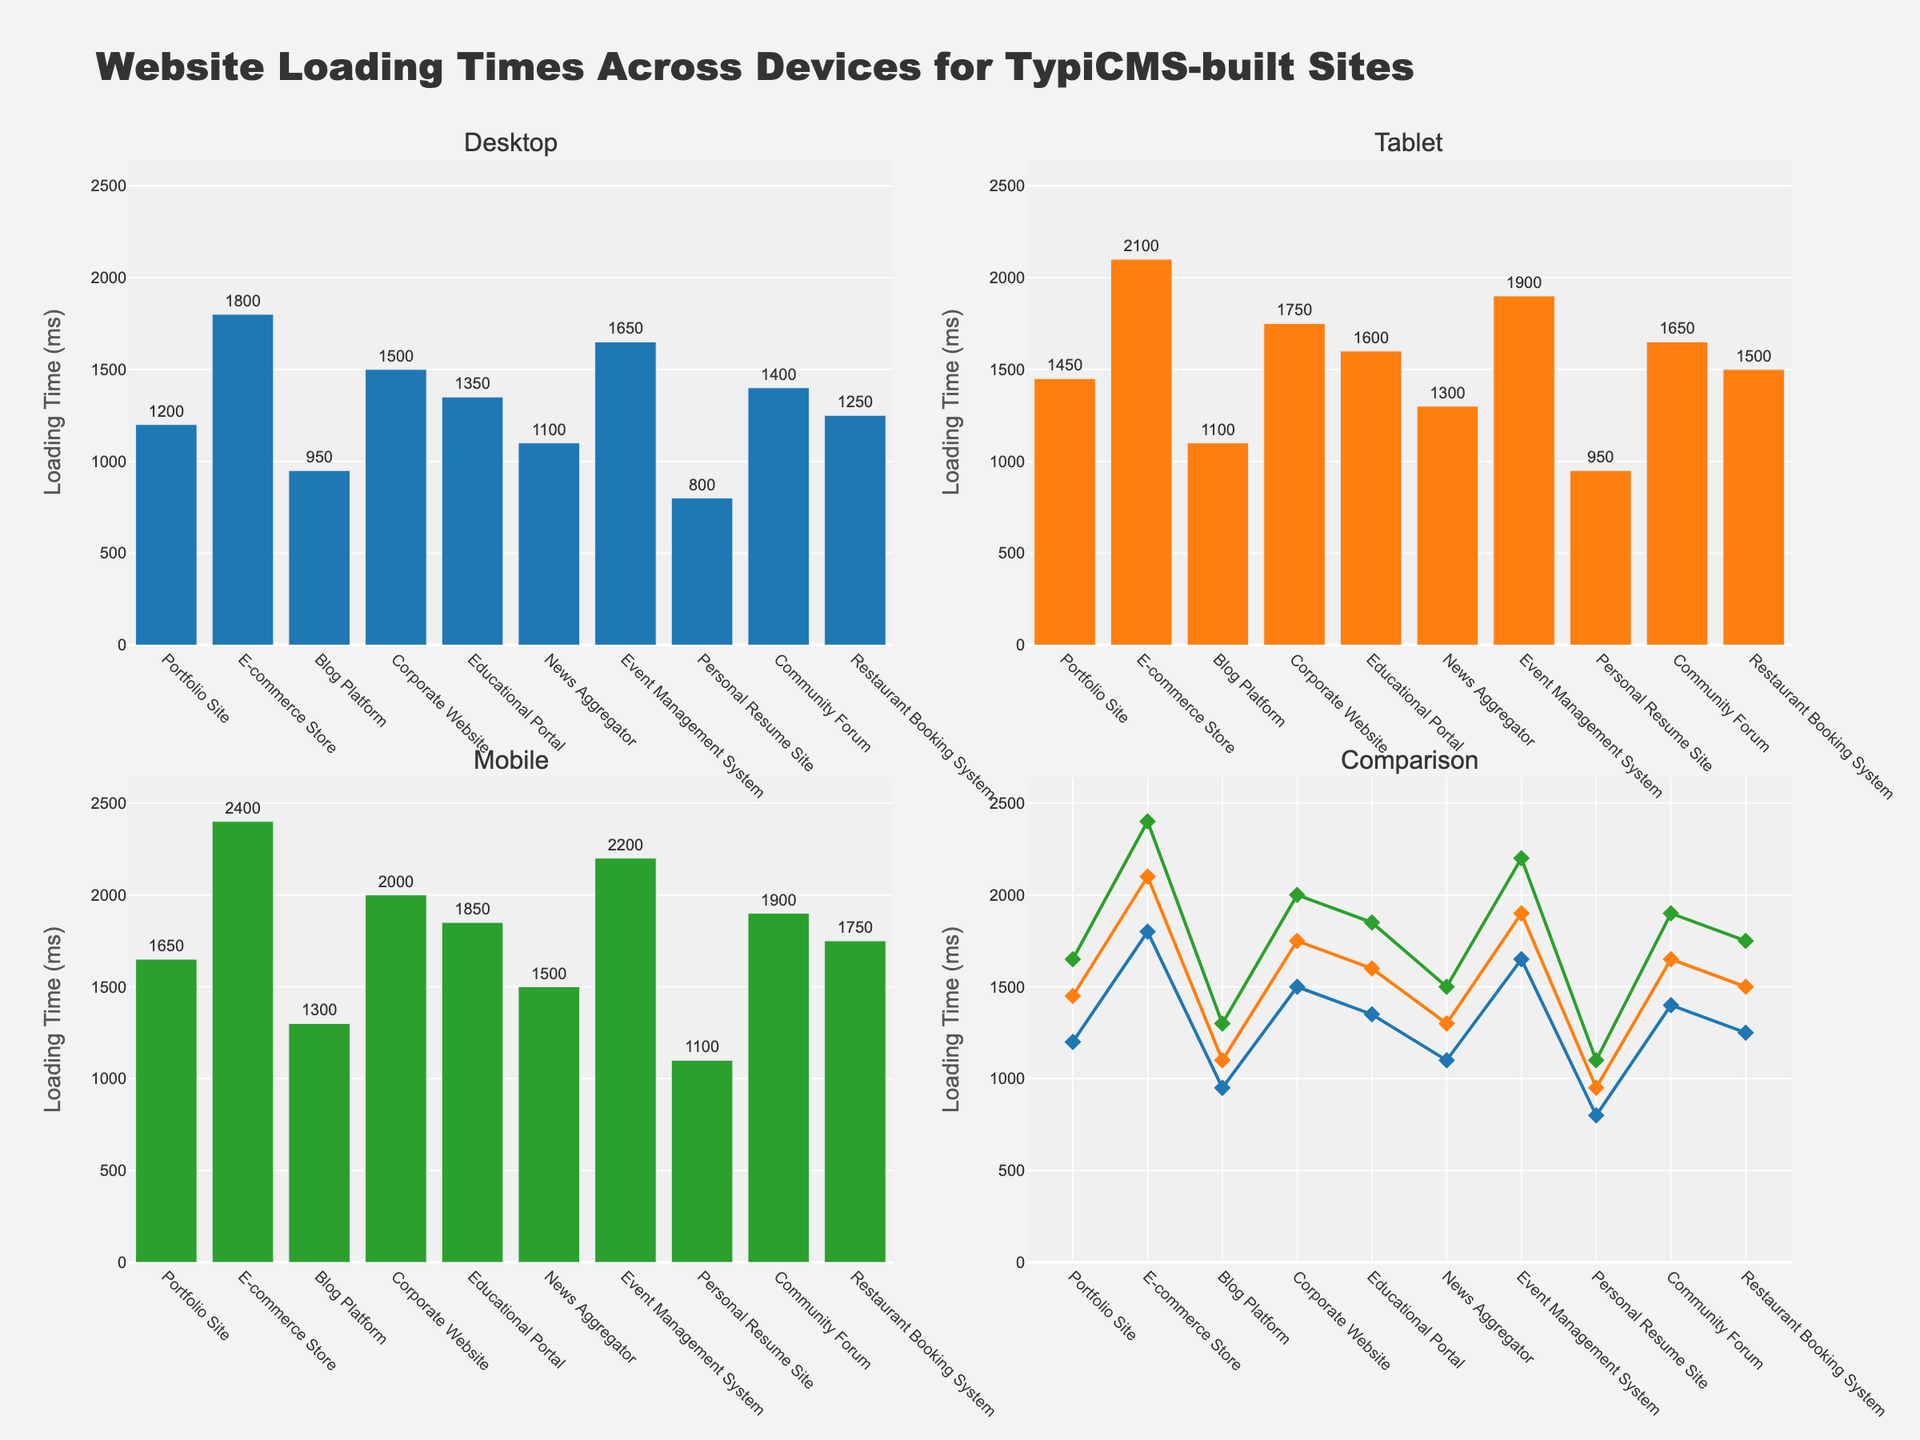How many subplots are there in the figure? Count the number of individual plots visible in the figure. There are two rows and two columns, making a total of 4 subplots.
Answer: 4 Which device has the fastest loading time overall? Refer to the bar and scatter plots and identify the device bar or line with the smallest loading times for any site. The fastest is the Personal Resume Site on Desktop, which has 800 ms.
Answer: Desktop Which website has the longest loading time on mobile devices? Look at the 'Mobile' subplot and identify the tallest bar representing loading time across the data points for each site. The E-commerce Store has the longest loading time of 2400 ms.
Answer: E-commerce Store On average, do websites load faster on tablets or desktops? Compare the average of loading times for all the websites between tablets and desktops. Sum the values for tablets and desktops, then divide by the number of sites in each category. (950+1100+1300+1450+1500+1600+1650+1750+2100+2400)/10 = 1665 ms (Tablet); (800+950+1100+1200+1250+1350+1400+1500+1650+1800)/10 = 1200 ms (Desktop)
Answer: Desktops Which website shows the smallest difference between loading times on mobile and desktop devices? Calculate the difference between the loading times for mobile and desktop devices for each website, and identify the minimum value.
Answer: Portfolio Site (Difference: 450 ms) Rank the websites from fastest to slowest loading on desktops. Order the loading times on desktops from lowest to highest across the websites.
Answer: Personal Resume Site, Blog Platform, News Aggregator, Portfolio Site, Restaurant Booking System, Educational Portal, Community Forum, Corporate Website, Event Management System, E-commerce Store For the Community Forum, by how much does the loading time increase from desktop to mobile? Subtract the loading time on desktops from the loading time on mobiles for the Community Forum. 1900 ms (Mobile) - 1400 ms (Desktop) = 500 ms
Answer: 500 ms Compare the loading times between News Aggregator and Educational Portal on tablet devices. Which loads faster? Look at the tablet subplot and compare the bars for News Aggregator and Educational Portal, identifying which has the smaller loading time. News Aggregator loads at 1300 ms, whereas Educational Portal loads at 1600 ms.
Answer: News Aggregator In the comparison subplot, which device's trend line consistently shows higher loading times as website types change? Observe the trend lines for desktop, tablet, and mobile in the comparison subplot. The mobile device trend line consistently shows higher values compared to the others.
Answer: Mobile 